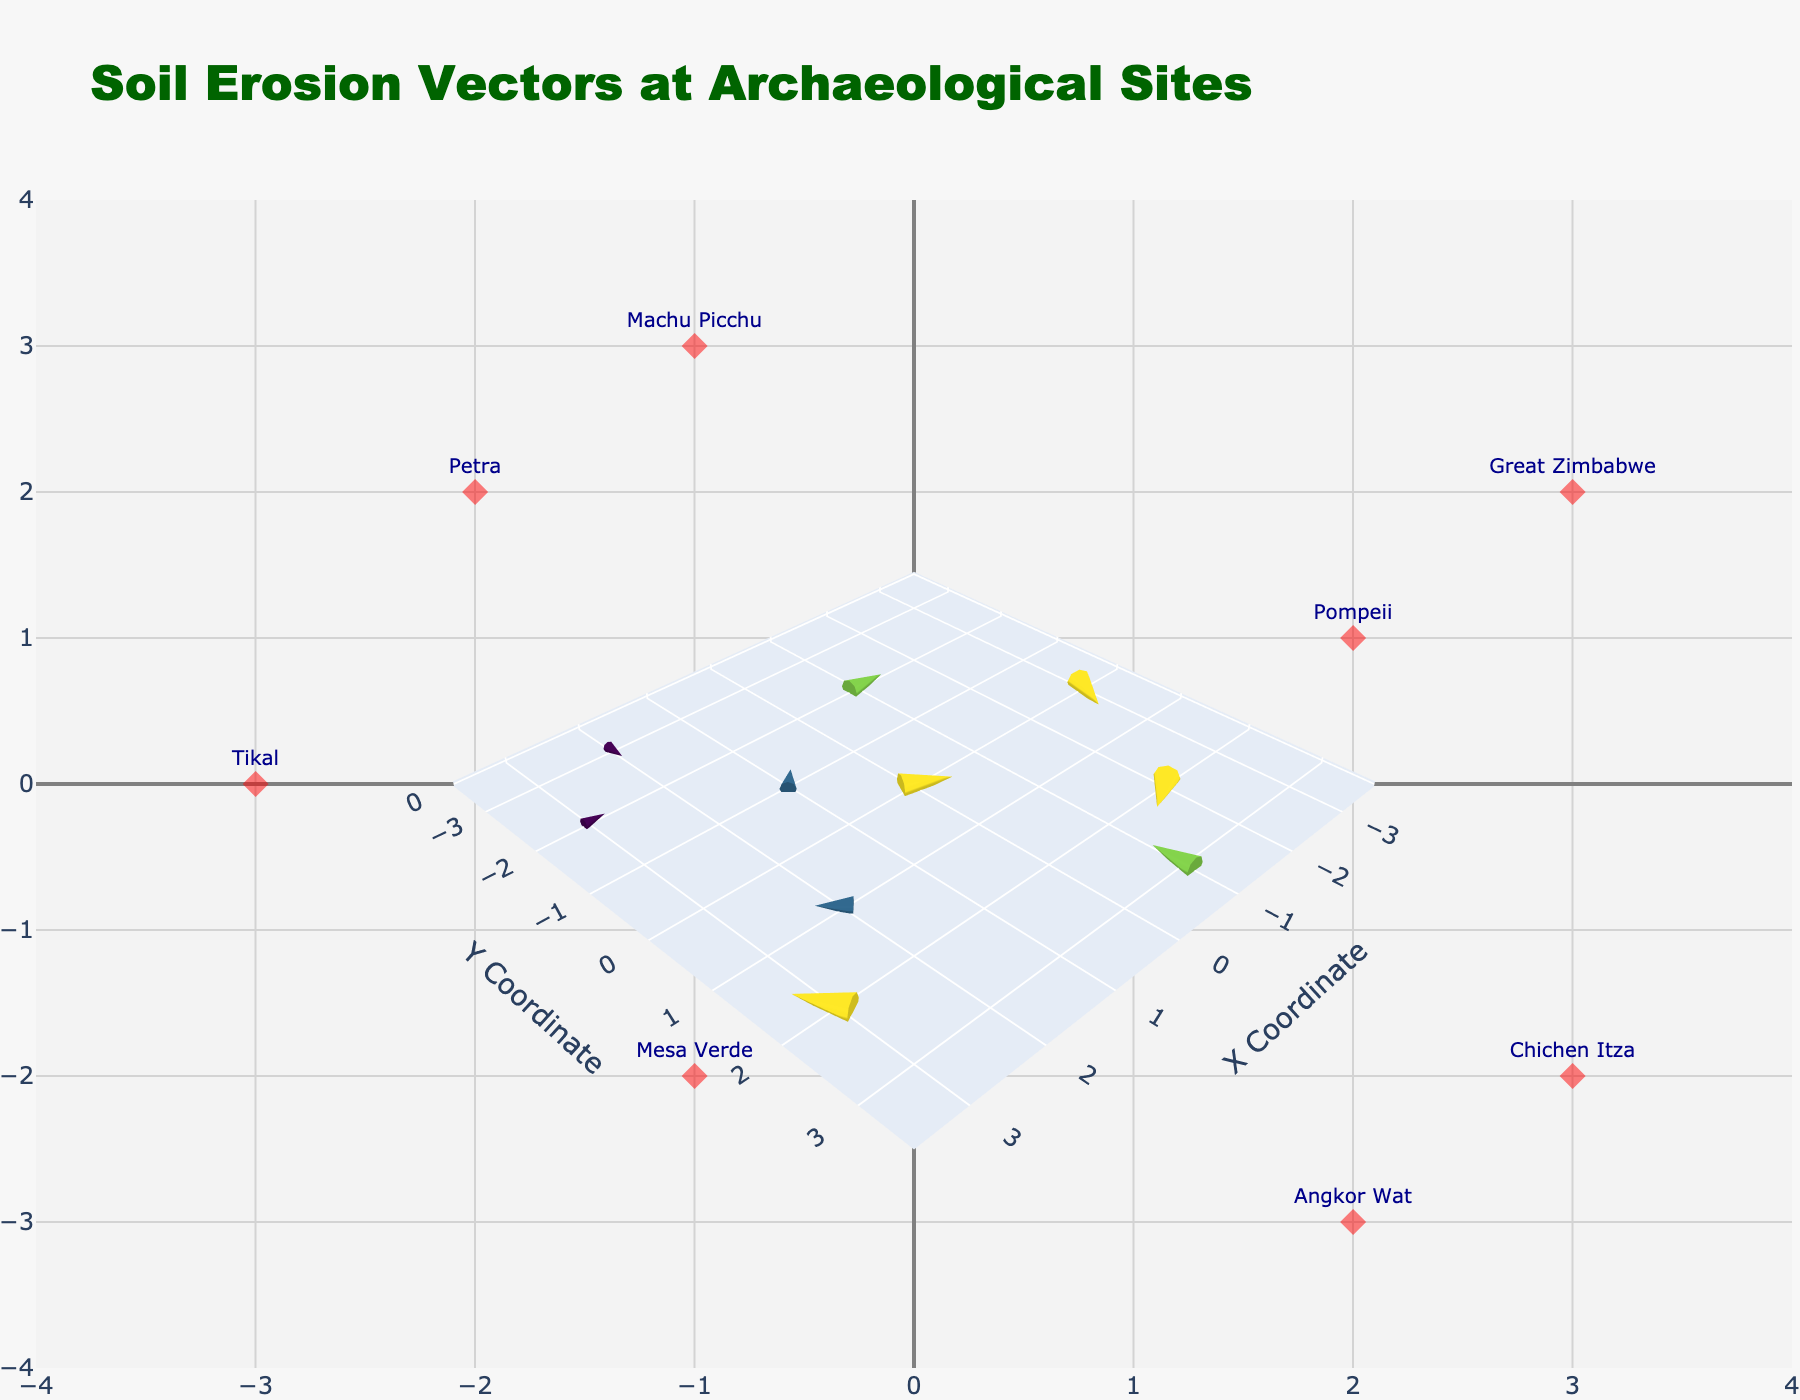How many total archaeological sites are represented in the figure? Count the number of unique site labels shown on the plot. There are 10 unique sites labeled around the plot after counting.
Answer: 10 Which archaeological site has the largest Y vector in magnitude? Observe the vector values and compare the magnitudes of the Y components. Machu Picchu has the largest Y vector with a magnitude of 2.
Answer: Machu Picchu What are the coordinates and vector (U, V) values of 'Tikal'? Identify the label 'Tikal' and note its coordinates and vector values from the plot. Coordinates (-3, 0) and vector (1, 2) are associated with Tikal.
Answer: (-3, 0), (1, 2) How many vectors have a negative U component? Count the vectors where the U component is less than zero. The vectors with negative U components are those of Gobekli Tepe, Chichen Itza, Mohenjo-daro, and Mesa Verde.
Answer: 4 What is the average length of the vectors (sqrt(U^2 + V^2)) in the plot? Sum the individual vector lengths and then divide by the number of vectors. The vector lengths are calculated as follows: (sqrt(2^2+1^2) + sqrt(1^2+1^1) + sqrt(0^2+2^2) + sqrt(1^2+0^2) + sqrt(2^2+1^2) + sqrt(1^2+1^1) + sqrt(1^2+2^2) + sqrt(0^2+1^2) + sqrt(2^2+0^2) + sqrt(1^2+2^2)) / 10 = (sqrt(5) + sqrt(2) + 2 + 1 + sqrt(5) + sqrt(2) + sqrt(5) + 1 + 2 + sqrt(5)) / 10. This equals approximately 1.79.
Answer: 1.79 Which site's vector points directly downwards? Observe which vector has a direction with a strictly negative V component and zero U component. Machu Picchu’s vector points directly downwards with coordinates (-1, 3) and vector (0, -2).
Answer: Machu Picchu Comparing the erosion vector magnitudes of Gobekli Tepe and Angkor Wat, which one is greater? Calculate the magnitudes for each site's vector: Gobekli Tepe’s vector is sqrt((-2)^2+(1)^2) = sqrt(5), and Angkor Wat’s vector is sqrt((0)^2+(1)^2) = 1. sqrt(5) is greater than 1.
Answer: Gobekli Tepe What is the range of X coordinates covered by the archaeological sites? Identify the minimum and maximum X coordinates among the data points of the sites. The minimum X coordinate is -3, and the maximum X coordinate is 3.
Answer: -3 to 3 Which vector has the steepest upward angle? Look for the vector with the largest positive V with respect to U. The vector for Tikal has the largest positive V component (2) relative to a small positive U component (1), suggesting a steep upward angle.
Answer: Tikal 